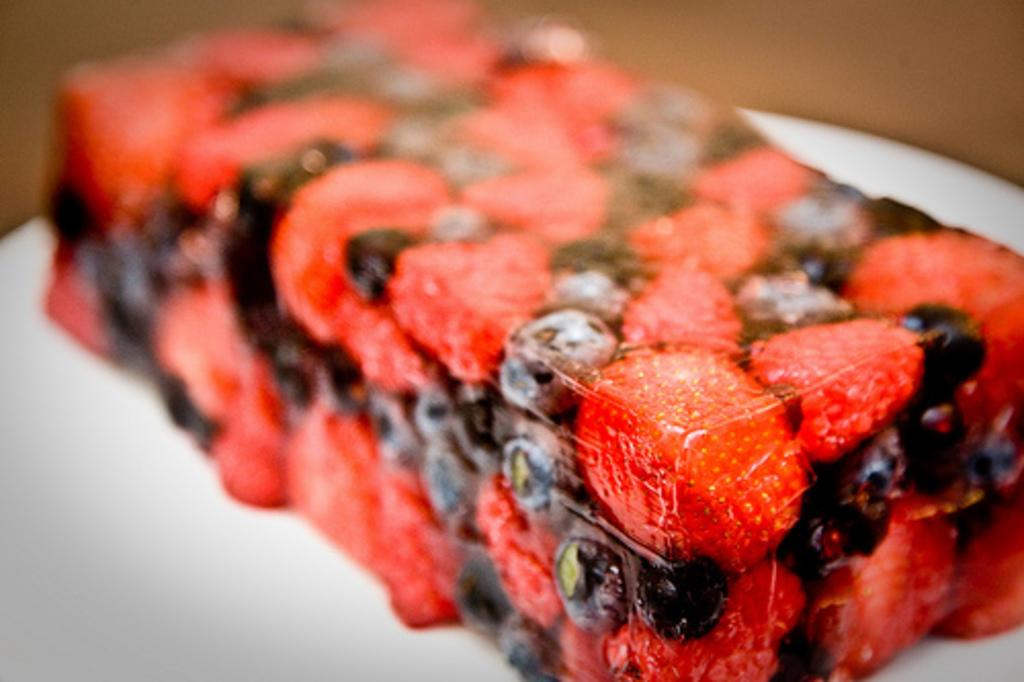What object is present on the plate in the image? There is a white plate in the image. What is on top of the plate? There is food on the plate. What colors can be seen in the food? The food has red and black colors. How would you describe the background of the image? The background of the image is blurred. How many leaves can be seen on the plate in the image? There are no leaves present on the plate in the image. 